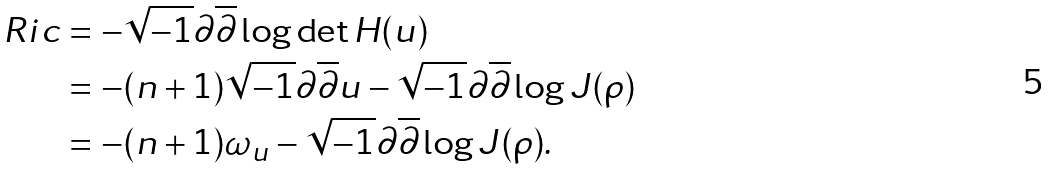Convert formula to latex. <formula><loc_0><loc_0><loc_500><loc_500>R i c & = - \sqrt { - 1 } \partial \overline { \partial } \log \det H ( u ) \\ & = - ( n + 1 ) \sqrt { - 1 } \partial \overline { \partial } u - \sqrt { - 1 } \partial \overline { \partial } \log J ( \rho ) \\ & = - ( n + 1 ) \omega _ { u } - \sqrt { - 1 } \partial \overline { \partial } \log J ( \rho ) .</formula> 